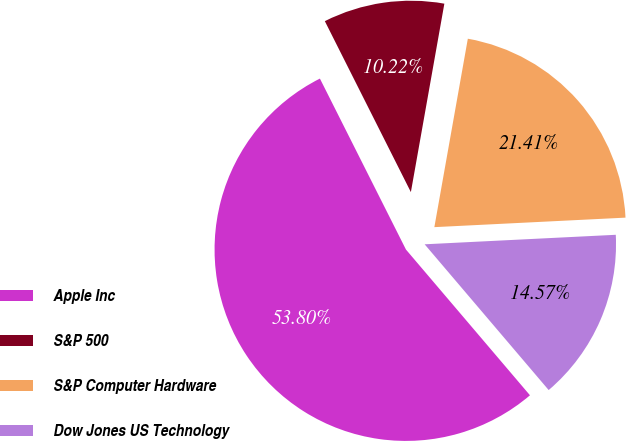Convert chart to OTSL. <chart><loc_0><loc_0><loc_500><loc_500><pie_chart><fcel>Apple Inc<fcel>S&P 500<fcel>S&P Computer Hardware<fcel>Dow Jones US Technology<nl><fcel>53.8%<fcel>10.22%<fcel>21.41%<fcel>14.57%<nl></chart> 